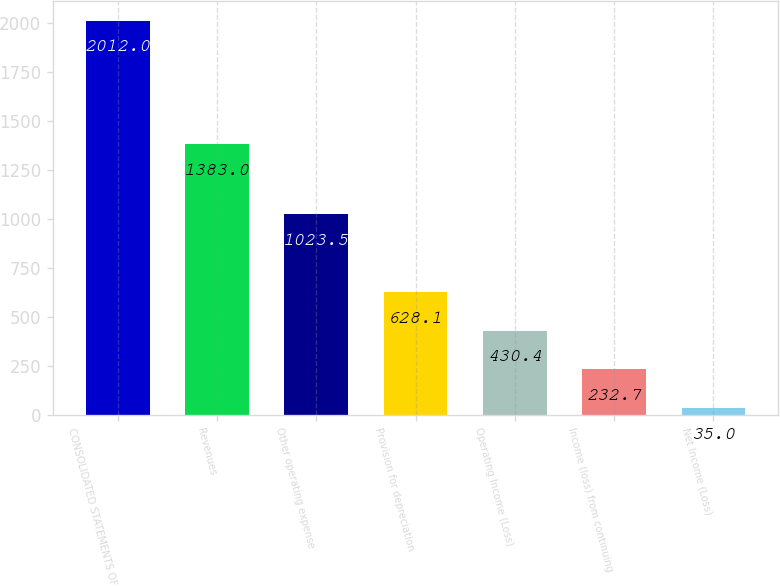<chart> <loc_0><loc_0><loc_500><loc_500><bar_chart><fcel>CONSOLIDATED STATEMENTS OF<fcel>Revenues<fcel>Other operating expense<fcel>Provision for depreciation<fcel>Operating Income (Loss)<fcel>Income (loss) from continuing<fcel>Net Income (Loss)<nl><fcel>2012<fcel>1383<fcel>1023.5<fcel>628.1<fcel>430.4<fcel>232.7<fcel>35<nl></chart> 